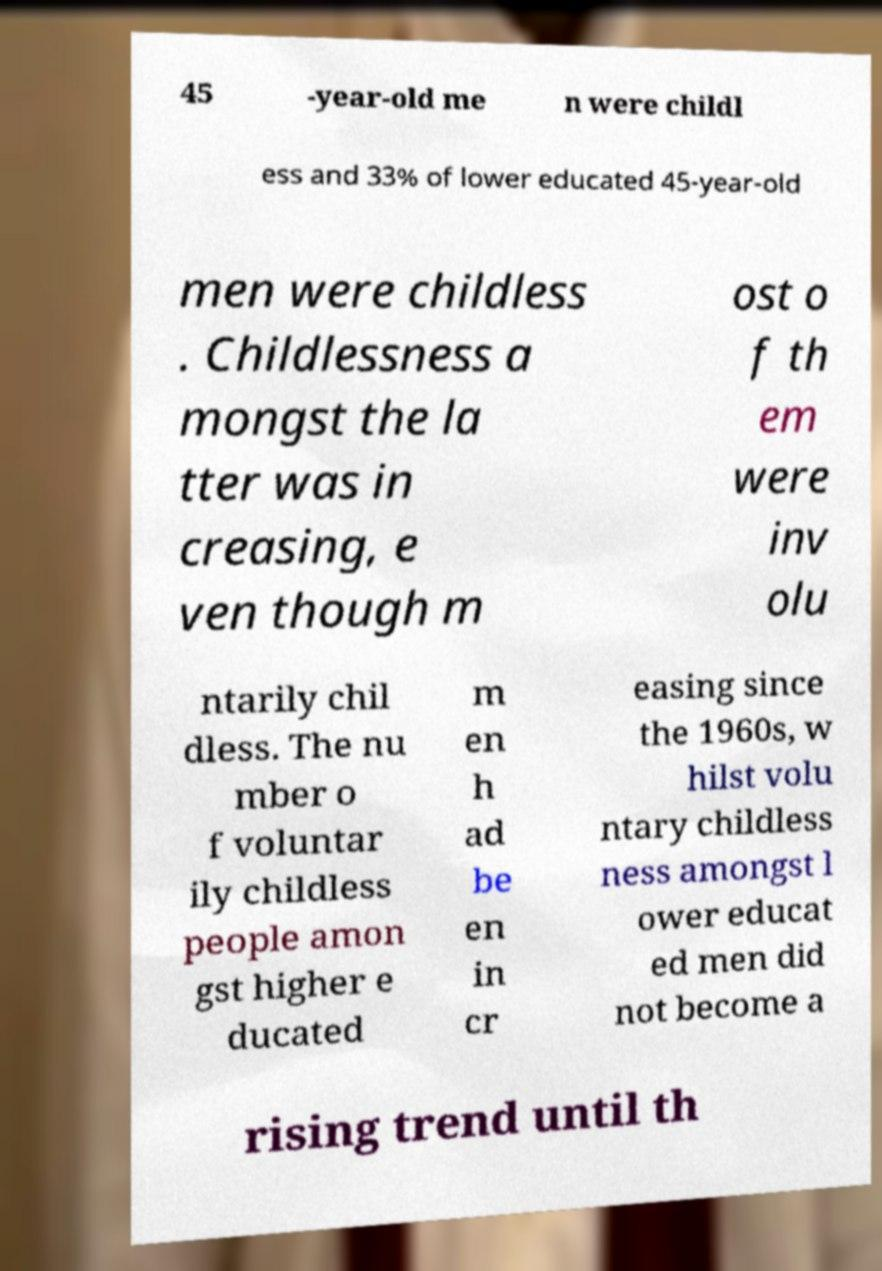What messages or text are displayed in this image? I need them in a readable, typed format. 45 -year-old me n were childl ess and 33% of lower educated 45-year-old men were childless . Childlessness a mongst the la tter was in creasing, e ven though m ost o f th em were inv olu ntarily chil dless. The nu mber o f voluntar ily childless people amon gst higher e ducated m en h ad be en in cr easing since the 1960s, w hilst volu ntary childless ness amongst l ower educat ed men did not become a rising trend until th 